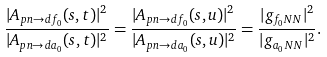<formula> <loc_0><loc_0><loc_500><loc_500>\frac { { | A _ { p n \to d f _ { 0 } } } ( s , t ) | ^ { 2 } } { | A _ { p n \to d a _ { 0 } } ( s , t ) | ^ { 2 } } = \frac { { | A _ { p n \to d f _ { 0 } } } ( s , u ) | ^ { 2 } } { | A _ { p n \to d a _ { 0 } } ( s , u ) | ^ { 2 } } = \frac { | g _ { f _ { 0 } N N } | ^ { 2 } } { | g _ { a _ { 0 } N N } | ^ { 2 } } .</formula> 